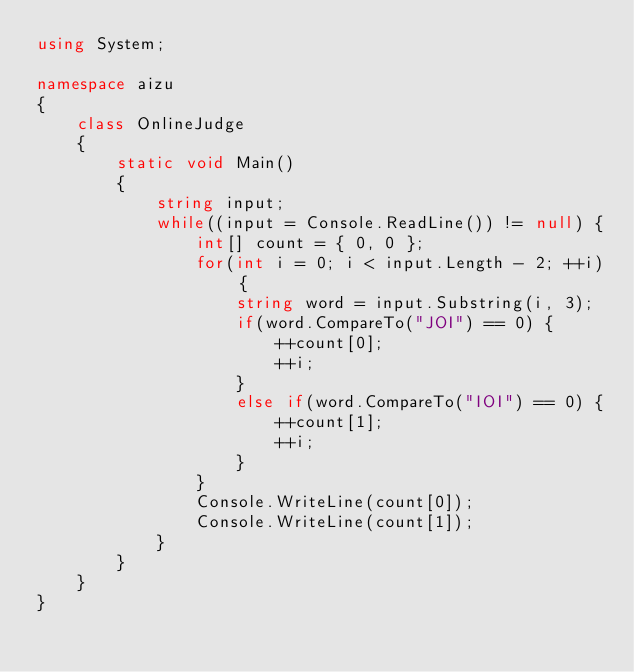Convert code to text. <code><loc_0><loc_0><loc_500><loc_500><_C#_>using System;

namespace aizu
{
    class OnlineJudge
    {
        static void Main()
        {
            string input;
            while((input = Console.ReadLine()) != null) {
                int[] count = { 0, 0 };
                for(int i = 0; i < input.Length - 2; ++i) {
                    string word = input.Substring(i, 3);
                    if(word.CompareTo("JOI") == 0) {
                        ++count[0];
                        ++i;
                    }
                    else if(word.CompareTo("IOI") == 0) {
                        ++count[1];
                        ++i;
                    }
                }
                Console.WriteLine(count[0]);
                Console.WriteLine(count[1]);
            }
        }
    }
}</code> 